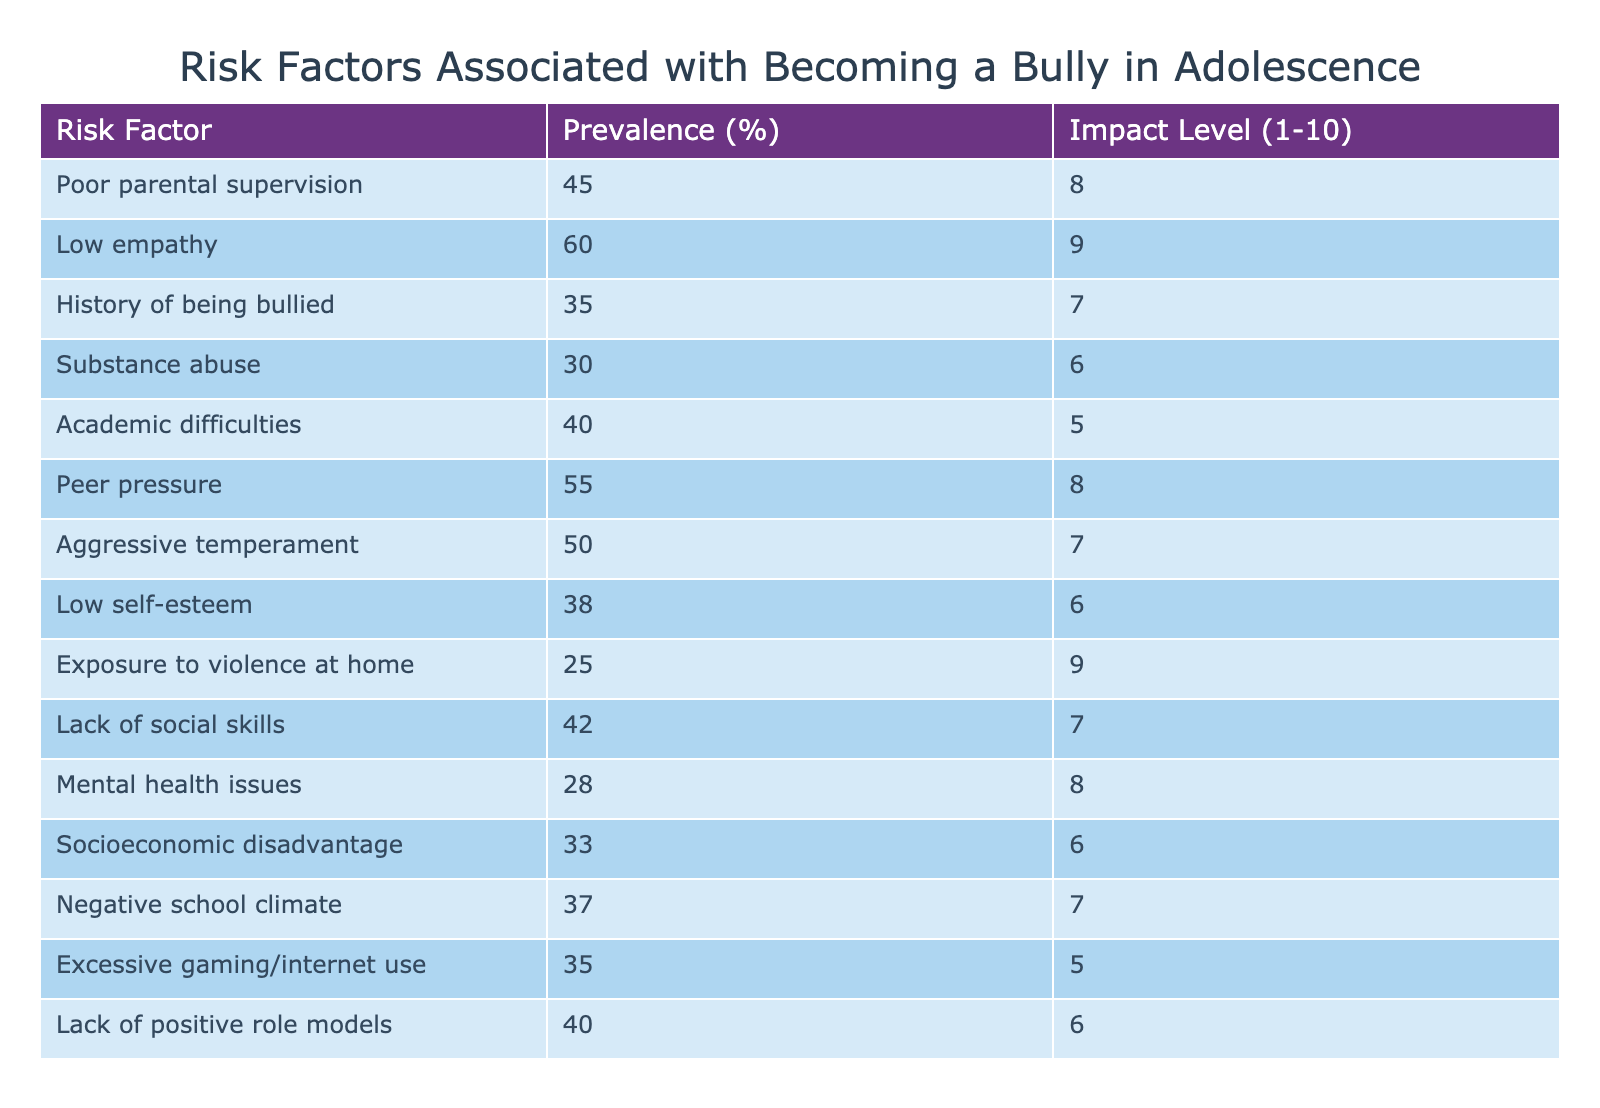What is the prevalence percentage of low empathy as a risk factor? The table shows that low empathy has a prevalence of 60%. This value is directly listed under the "Prevalence" column next to "Low empathy."
Answer: 60% Which risk factor has the highest impact level? By examining the "Impact Level" column, I find that low empathy has an impact level of 9, which is the highest in the list.
Answer: Low empathy What is the average prevalence of all listed risk factors? To find the average, I sum all the prevalence values (45 + 60 + 35 + 30 + 40 + 55 + 50 + 38 + 25 + 42 + 28 + 33 + 37 + 35 + 40) =  610. Then, I divide by the number of factors (15), resulting in an average of 610 / 15 = 40.67.
Answer: 40.67 Is exposure to violence at home a significant risk factor? Yes, with a prevalence of 25% and an impact level of 9, it is indeed significant as it has both notable prevalence and high impact.
Answer: Yes What is the difference in impact level between poor parental supervision and substance abuse? Poor parental supervision has an impact level of 8, while substance abuse has an impact level of 6. The difference is 8 - 6 = 2.
Answer: 2 How many risk factors have a prevalence of 40% or more? By reviewing the table, I can count the risk factors with a prevalence of 40% or greater, which are: poor parental supervision (45), low empathy (60), academic difficulties (40), peer pressure (55), aggressive temperament (50), lack of social skills (42), and lack of positive role models (40). This gives a total of 7 risk factors.
Answer: 7 Which risk factor has the lowest prevalence and what is its impact level? The factor with the lowest prevalence is exposure to violence at home at 25%, which has an impact level of 9. This information can be found directly in the table.
Answer: Exposure to violence at home, 9 What can be inferred about the relationship between low self-esteem and aggression in adolescents? Based on the table, low self-esteem has a prevalence of 38% and an impact level of 6. Compared to aggressive temperament, with a prevalence of 50% and an impact level of 7, we can infer that low self-esteem may contribute somewhat to aggression in adolescents but is not as strong a risk factor as aggressive temperament itself.
Answer: Low self-esteem contributes less than aggressive temperament Is there a notable trend between socioeconomic disadvantage and the prevalence of bullying? Socioeconomic disadvantage has a prevalence of 33% and an impact level of 6. When compared to other factors with higher prevalence like low empathy (60%) and peer pressure (55%), it suggests that while it is a risk factor, it is not among the most significant.
Answer: Yes, but not significant compared to others 